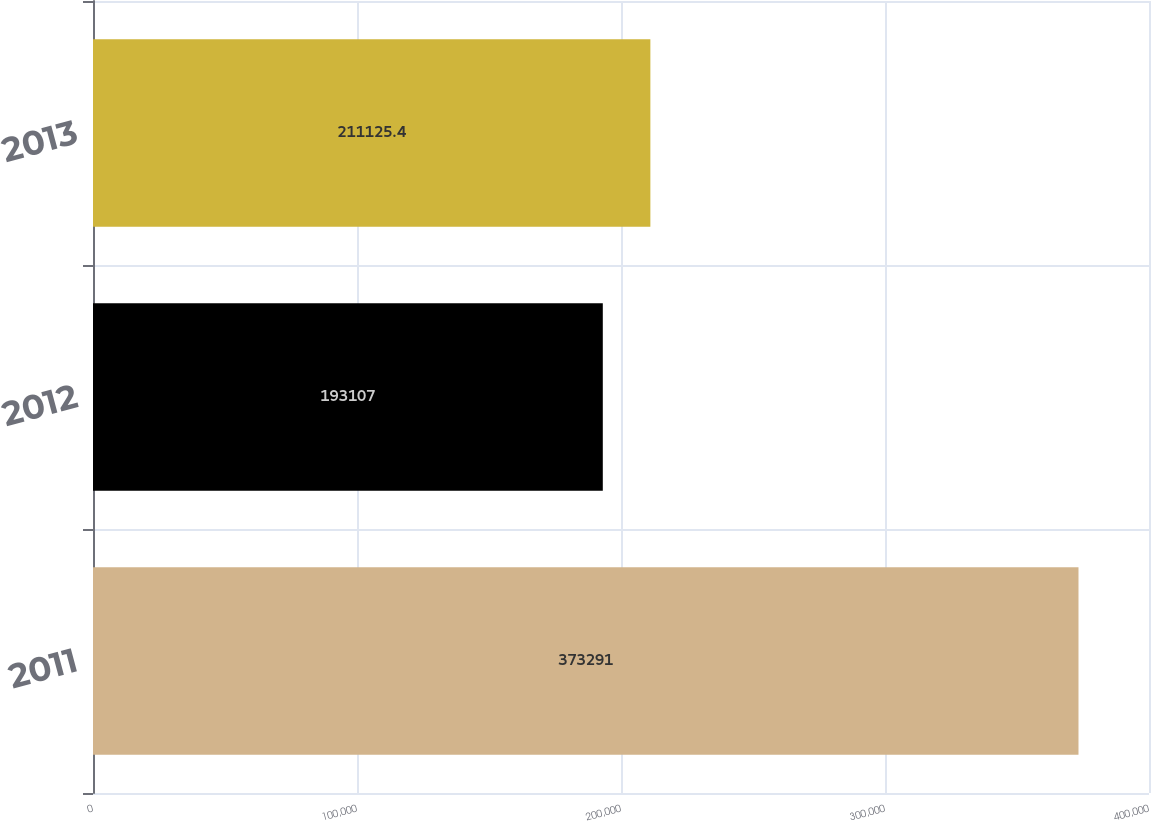<chart> <loc_0><loc_0><loc_500><loc_500><bar_chart><fcel>2011<fcel>2012<fcel>2013<nl><fcel>373291<fcel>193107<fcel>211125<nl></chart> 